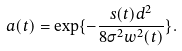Convert formula to latex. <formula><loc_0><loc_0><loc_500><loc_500>a ( t ) = \exp \{ - { \frac { s ( t ) d ^ { 2 } } { 8 \sigma ^ { 2 } w ^ { 2 } ( t ) } } \} .</formula> 